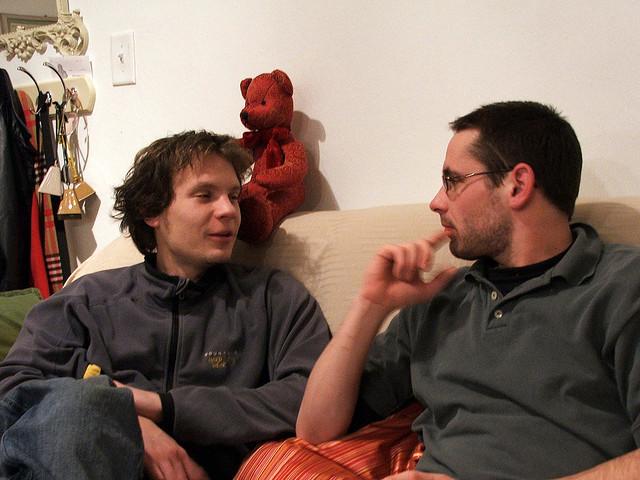What stuffed animal is on the couch?
Answer briefly. Teddy bear. Of the two figures sitting in the middle of the photo, which is sitting closer to the viewer?
Give a very brief answer. Right. Which person is wearing glasses?
Short answer required. Right. What are these people doing?
Keep it brief. Talking. What color is the man's beard?
Write a very short answer. Black. How many of the men are wearing hats?
Short answer required. 0. Is the man looking at his phone?
Short answer required. No. How many people are shown?
Be succinct. 2. 